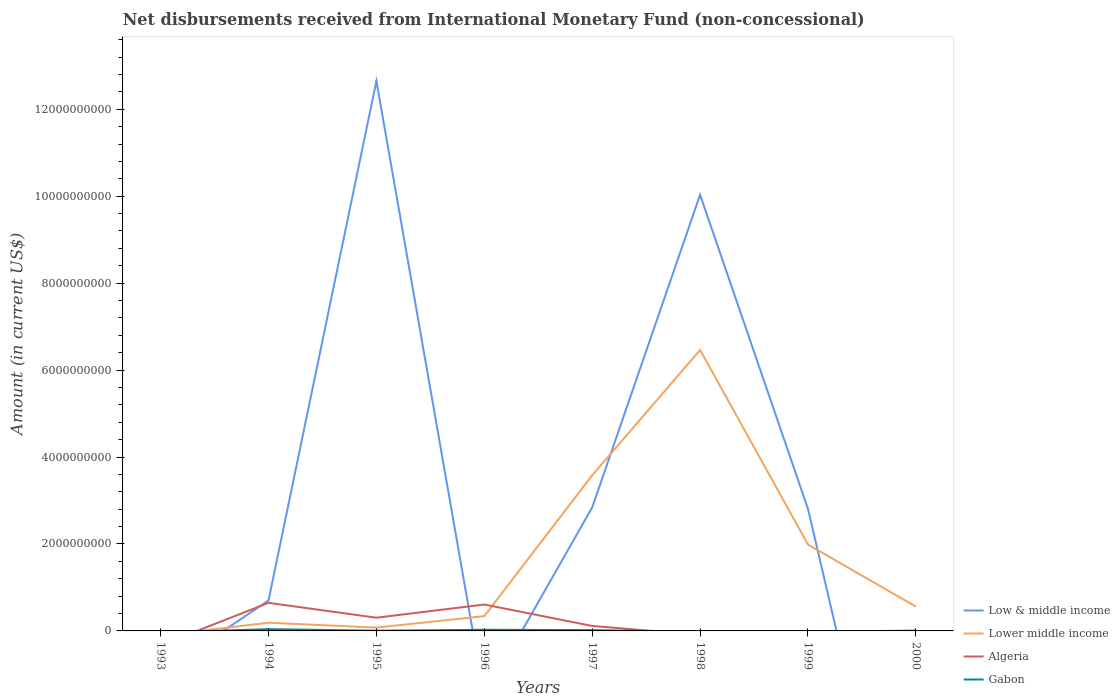Across all years, what is the maximum amount of disbursements received from International Monetary Fund in Low & middle income?
Keep it short and to the point. 0. What is the total amount of disbursements received from International Monetary Fund in Gabon in the graph?
Ensure brevity in your answer.  1.16e+07. What is the difference between the highest and the second highest amount of disbursements received from International Monetary Fund in Algeria?
Provide a short and direct response. 6.46e+08. How many years are there in the graph?
Ensure brevity in your answer.  8. Does the graph contain grids?
Make the answer very short. No. How many legend labels are there?
Offer a very short reply. 4. How are the legend labels stacked?
Keep it short and to the point. Vertical. What is the title of the graph?
Keep it short and to the point. Net disbursements received from International Monetary Fund (non-concessional). Does "Bangladesh" appear as one of the legend labels in the graph?
Provide a succinct answer. No. What is the Amount (in current US$) in Low & middle income in 1993?
Offer a terse response. 0. What is the Amount (in current US$) of Lower middle income in 1993?
Your response must be concise. 0. What is the Amount (in current US$) in Low & middle income in 1994?
Your answer should be very brief. 7.00e+08. What is the Amount (in current US$) of Lower middle income in 1994?
Offer a very short reply. 1.88e+08. What is the Amount (in current US$) of Algeria in 1994?
Ensure brevity in your answer.  6.46e+08. What is the Amount (in current US$) of Gabon in 1994?
Your answer should be very brief. 4.09e+07. What is the Amount (in current US$) in Low & middle income in 1995?
Your answer should be compact. 1.26e+1. What is the Amount (in current US$) in Lower middle income in 1995?
Offer a terse response. 7.66e+07. What is the Amount (in current US$) in Algeria in 1995?
Your answer should be compact. 3.04e+08. What is the Amount (in current US$) of Gabon in 1995?
Make the answer very short. 5.36e+06. What is the Amount (in current US$) in Lower middle income in 1996?
Keep it short and to the point. 3.40e+08. What is the Amount (in current US$) of Algeria in 1996?
Your answer should be compact. 6.08e+08. What is the Amount (in current US$) in Gabon in 1996?
Offer a very short reply. 2.66e+07. What is the Amount (in current US$) in Low & middle income in 1997?
Give a very brief answer. 2.84e+09. What is the Amount (in current US$) of Lower middle income in 1997?
Your answer should be compact. 3.58e+09. What is the Amount (in current US$) of Algeria in 1997?
Offer a very short reply. 1.14e+08. What is the Amount (in current US$) of Gabon in 1997?
Offer a very short reply. 1.92e+07. What is the Amount (in current US$) of Low & middle income in 1998?
Your answer should be compact. 1.00e+1. What is the Amount (in current US$) of Lower middle income in 1998?
Your answer should be compact. 6.46e+09. What is the Amount (in current US$) in Gabon in 1998?
Your answer should be compact. 0. What is the Amount (in current US$) of Low & middle income in 1999?
Offer a very short reply. 2.81e+09. What is the Amount (in current US$) in Lower middle income in 1999?
Offer a very short reply. 1.99e+09. What is the Amount (in current US$) in Low & middle income in 2000?
Keep it short and to the point. 0. What is the Amount (in current US$) of Lower middle income in 2000?
Provide a short and direct response. 5.59e+08. What is the Amount (in current US$) of Gabon in 2000?
Provide a short and direct response. 7.62e+06. Across all years, what is the maximum Amount (in current US$) of Low & middle income?
Ensure brevity in your answer.  1.26e+1. Across all years, what is the maximum Amount (in current US$) in Lower middle income?
Your answer should be compact. 6.46e+09. Across all years, what is the maximum Amount (in current US$) in Algeria?
Make the answer very short. 6.46e+08. Across all years, what is the maximum Amount (in current US$) of Gabon?
Keep it short and to the point. 4.09e+07. What is the total Amount (in current US$) in Low & middle income in the graph?
Your answer should be compact. 2.90e+1. What is the total Amount (in current US$) of Lower middle income in the graph?
Offer a terse response. 1.32e+1. What is the total Amount (in current US$) in Algeria in the graph?
Offer a very short reply. 1.67e+09. What is the total Amount (in current US$) of Gabon in the graph?
Ensure brevity in your answer.  9.96e+07. What is the difference between the Amount (in current US$) of Low & middle income in 1994 and that in 1995?
Make the answer very short. -1.19e+1. What is the difference between the Amount (in current US$) of Lower middle income in 1994 and that in 1995?
Make the answer very short. 1.11e+08. What is the difference between the Amount (in current US$) of Algeria in 1994 and that in 1995?
Keep it short and to the point. 3.42e+08. What is the difference between the Amount (in current US$) in Gabon in 1994 and that in 1995?
Offer a very short reply. 3.55e+07. What is the difference between the Amount (in current US$) in Lower middle income in 1994 and that in 1996?
Keep it short and to the point. -1.52e+08. What is the difference between the Amount (in current US$) of Algeria in 1994 and that in 1996?
Give a very brief answer. 3.84e+07. What is the difference between the Amount (in current US$) of Gabon in 1994 and that in 1996?
Provide a succinct answer. 1.43e+07. What is the difference between the Amount (in current US$) in Low & middle income in 1994 and that in 1997?
Offer a very short reply. -2.14e+09. What is the difference between the Amount (in current US$) in Lower middle income in 1994 and that in 1997?
Provide a succinct answer. -3.39e+09. What is the difference between the Amount (in current US$) of Algeria in 1994 and that in 1997?
Your answer should be very brief. 5.32e+08. What is the difference between the Amount (in current US$) in Gabon in 1994 and that in 1997?
Give a very brief answer. 2.17e+07. What is the difference between the Amount (in current US$) in Low & middle income in 1994 and that in 1998?
Offer a very short reply. -9.33e+09. What is the difference between the Amount (in current US$) of Lower middle income in 1994 and that in 1998?
Your answer should be compact. -6.28e+09. What is the difference between the Amount (in current US$) of Low & middle income in 1994 and that in 1999?
Keep it short and to the point. -2.11e+09. What is the difference between the Amount (in current US$) in Lower middle income in 1994 and that in 1999?
Your response must be concise. -1.80e+09. What is the difference between the Amount (in current US$) in Lower middle income in 1994 and that in 2000?
Keep it short and to the point. -3.71e+08. What is the difference between the Amount (in current US$) of Gabon in 1994 and that in 2000?
Keep it short and to the point. 3.32e+07. What is the difference between the Amount (in current US$) in Lower middle income in 1995 and that in 1996?
Provide a short and direct response. -2.64e+08. What is the difference between the Amount (in current US$) of Algeria in 1995 and that in 1996?
Offer a terse response. -3.04e+08. What is the difference between the Amount (in current US$) in Gabon in 1995 and that in 1996?
Give a very brief answer. -2.12e+07. What is the difference between the Amount (in current US$) in Low & middle income in 1995 and that in 1997?
Ensure brevity in your answer.  9.81e+09. What is the difference between the Amount (in current US$) in Lower middle income in 1995 and that in 1997?
Provide a short and direct response. -3.50e+09. What is the difference between the Amount (in current US$) of Algeria in 1995 and that in 1997?
Give a very brief answer. 1.90e+08. What is the difference between the Amount (in current US$) in Gabon in 1995 and that in 1997?
Make the answer very short. -1.38e+07. What is the difference between the Amount (in current US$) in Low & middle income in 1995 and that in 1998?
Your answer should be very brief. 2.62e+09. What is the difference between the Amount (in current US$) in Lower middle income in 1995 and that in 1998?
Your answer should be very brief. -6.39e+09. What is the difference between the Amount (in current US$) in Low & middle income in 1995 and that in 1999?
Offer a terse response. 9.84e+09. What is the difference between the Amount (in current US$) of Lower middle income in 1995 and that in 1999?
Keep it short and to the point. -1.91e+09. What is the difference between the Amount (in current US$) of Lower middle income in 1995 and that in 2000?
Make the answer very short. -4.82e+08. What is the difference between the Amount (in current US$) of Gabon in 1995 and that in 2000?
Provide a short and direct response. -2.26e+06. What is the difference between the Amount (in current US$) in Lower middle income in 1996 and that in 1997?
Provide a short and direct response. -3.24e+09. What is the difference between the Amount (in current US$) of Algeria in 1996 and that in 1997?
Offer a terse response. 4.93e+08. What is the difference between the Amount (in current US$) in Gabon in 1996 and that in 1997?
Your answer should be very brief. 7.40e+06. What is the difference between the Amount (in current US$) in Lower middle income in 1996 and that in 1998?
Offer a very short reply. -6.12e+09. What is the difference between the Amount (in current US$) in Lower middle income in 1996 and that in 1999?
Offer a terse response. -1.65e+09. What is the difference between the Amount (in current US$) in Lower middle income in 1996 and that in 2000?
Make the answer very short. -2.18e+08. What is the difference between the Amount (in current US$) of Gabon in 1996 and that in 2000?
Give a very brief answer. 1.90e+07. What is the difference between the Amount (in current US$) in Low & middle income in 1997 and that in 1998?
Offer a very short reply. -7.19e+09. What is the difference between the Amount (in current US$) of Lower middle income in 1997 and that in 1998?
Offer a very short reply. -2.88e+09. What is the difference between the Amount (in current US$) of Low & middle income in 1997 and that in 1999?
Make the answer very short. 3.42e+07. What is the difference between the Amount (in current US$) of Lower middle income in 1997 and that in 1999?
Give a very brief answer. 1.59e+09. What is the difference between the Amount (in current US$) of Lower middle income in 1997 and that in 2000?
Give a very brief answer. 3.02e+09. What is the difference between the Amount (in current US$) of Gabon in 1997 and that in 2000?
Your response must be concise. 1.16e+07. What is the difference between the Amount (in current US$) in Low & middle income in 1998 and that in 1999?
Keep it short and to the point. 7.23e+09. What is the difference between the Amount (in current US$) in Lower middle income in 1998 and that in 1999?
Offer a terse response. 4.48e+09. What is the difference between the Amount (in current US$) in Lower middle income in 1998 and that in 2000?
Your answer should be compact. 5.90e+09. What is the difference between the Amount (in current US$) in Lower middle income in 1999 and that in 2000?
Your answer should be compact. 1.43e+09. What is the difference between the Amount (in current US$) in Low & middle income in 1994 and the Amount (in current US$) in Lower middle income in 1995?
Provide a short and direct response. 6.23e+08. What is the difference between the Amount (in current US$) of Low & middle income in 1994 and the Amount (in current US$) of Algeria in 1995?
Ensure brevity in your answer.  3.96e+08. What is the difference between the Amount (in current US$) of Low & middle income in 1994 and the Amount (in current US$) of Gabon in 1995?
Offer a very short reply. 6.95e+08. What is the difference between the Amount (in current US$) of Lower middle income in 1994 and the Amount (in current US$) of Algeria in 1995?
Provide a short and direct response. -1.16e+08. What is the difference between the Amount (in current US$) in Lower middle income in 1994 and the Amount (in current US$) in Gabon in 1995?
Your answer should be compact. 1.83e+08. What is the difference between the Amount (in current US$) of Algeria in 1994 and the Amount (in current US$) of Gabon in 1995?
Provide a short and direct response. 6.41e+08. What is the difference between the Amount (in current US$) of Low & middle income in 1994 and the Amount (in current US$) of Lower middle income in 1996?
Give a very brief answer. 3.60e+08. What is the difference between the Amount (in current US$) of Low & middle income in 1994 and the Amount (in current US$) of Algeria in 1996?
Ensure brevity in your answer.  9.26e+07. What is the difference between the Amount (in current US$) of Low & middle income in 1994 and the Amount (in current US$) of Gabon in 1996?
Offer a very short reply. 6.74e+08. What is the difference between the Amount (in current US$) in Lower middle income in 1994 and the Amount (in current US$) in Algeria in 1996?
Your response must be concise. -4.19e+08. What is the difference between the Amount (in current US$) of Lower middle income in 1994 and the Amount (in current US$) of Gabon in 1996?
Provide a short and direct response. 1.62e+08. What is the difference between the Amount (in current US$) of Algeria in 1994 and the Amount (in current US$) of Gabon in 1996?
Give a very brief answer. 6.19e+08. What is the difference between the Amount (in current US$) of Low & middle income in 1994 and the Amount (in current US$) of Lower middle income in 1997?
Provide a short and direct response. -2.88e+09. What is the difference between the Amount (in current US$) in Low & middle income in 1994 and the Amount (in current US$) in Algeria in 1997?
Ensure brevity in your answer.  5.86e+08. What is the difference between the Amount (in current US$) of Low & middle income in 1994 and the Amount (in current US$) of Gabon in 1997?
Offer a very short reply. 6.81e+08. What is the difference between the Amount (in current US$) of Lower middle income in 1994 and the Amount (in current US$) of Algeria in 1997?
Your response must be concise. 7.40e+07. What is the difference between the Amount (in current US$) in Lower middle income in 1994 and the Amount (in current US$) in Gabon in 1997?
Make the answer very short. 1.69e+08. What is the difference between the Amount (in current US$) of Algeria in 1994 and the Amount (in current US$) of Gabon in 1997?
Keep it short and to the point. 6.27e+08. What is the difference between the Amount (in current US$) of Low & middle income in 1994 and the Amount (in current US$) of Lower middle income in 1998?
Offer a very short reply. -5.76e+09. What is the difference between the Amount (in current US$) in Low & middle income in 1994 and the Amount (in current US$) in Lower middle income in 1999?
Make the answer very short. -1.29e+09. What is the difference between the Amount (in current US$) in Low & middle income in 1994 and the Amount (in current US$) in Lower middle income in 2000?
Give a very brief answer. 1.41e+08. What is the difference between the Amount (in current US$) of Low & middle income in 1994 and the Amount (in current US$) of Gabon in 2000?
Offer a very short reply. 6.92e+08. What is the difference between the Amount (in current US$) of Lower middle income in 1994 and the Amount (in current US$) of Gabon in 2000?
Keep it short and to the point. 1.81e+08. What is the difference between the Amount (in current US$) of Algeria in 1994 and the Amount (in current US$) of Gabon in 2000?
Make the answer very short. 6.38e+08. What is the difference between the Amount (in current US$) in Low & middle income in 1995 and the Amount (in current US$) in Lower middle income in 1996?
Make the answer very short. 1.23e+1. What is the difference between the Amount (in current US$) of Low & middle income in 1995 and the Amount (in current US$) of Algeria in 1996?
Give a very brief answer. 1.20e+1. What is the difference between the Amount (in current US$) of Low & middle income in 1995 and the Amount (in current US$) of Gabon in 1996?
Provide a succinct answer. 1.26e+1. What is the difference between the Amount (in current US$) in Lower middle income in 1995 and the Amount (in current US$) in Algeria in 1996?
Your answer should be very brief. -5.31e+08. What is the difference between the Amount (in current US$) of Lower middle income in 1995 and the Amount (in current US$) of Gabon in 1996?
Keep it short and to the point. 5.01e+07. What is the difference between the Amount (in current US$) of Algeria in 1995 and the Amount (in current US$) of Gabon in 1996?
Keep it short and to the point. 2.77e+08. What is the difference between the Amount (in current US$) of Low & middle income in 1995 and the Amount (in current US$) of Lower middle income in 1997?
Ensure brevity in your answer.  9.07e+09. What is the difference between the Amount (in current US$) in Low & middle income in 1995 and the Amount (in current US$) in Algeria in 1997?
Offer a terse response. 1.25e+1. What is the difference between the Amount (in current US$) of Low & middle income in 1995 and the Amount (in current US$) of Gabon in 1997?
Keep it short and to the point. 1.26e+1. What is the difference between the Amount (in current US$) in Lower middle income in 1995 and the Amount (in current US$) in Algeria in 1997?
Make the answer very short. -3.75e+07. What is the difference between the Amount (in current US$) of Lower middle income in 1995 and the Amount (in current US$) of Gabon in 1997?
Give a very brief answer. 5.75e+07. What is the difference between the Amount (in current US$) in Algeria in 1995 and the Amount (in current US$) in Gabon in 1997?
Ensure brevity in your answer.  2.85e+08. What is the difference between the Amount (in current US$) of Low & middle income in 1995 and the Amount (in current US$) of Lower middle income in 1998?
Offer a very short reply. 6.19e+09. What is the difference between the Amount (in current US$) in Low & middle income in 1995 and the Amount (in current US$) in Lower middle income in 1999?
Provide a succinct answer. 1.07e+1. What is the difference between the Amount (in current US$) in Low & middle income in 1995 and the Amount (in current US$) in Lower middle income in 2000?
Ensure brevity in your answer.  1.21e+1. What is the difference between the Amount (in current US$) in Low & middle income in 1995 and the Amount (in current US$) in Gabon in 2000?
Your answer should be compact. 1.26e+1. What is the difference between the Amount (in current US$) of Lower middle income in 1995 and the Amount (in current US$) of Gabon in 2000?
Ensure brevity in your answer.  6.90e+07. What is the difference between the Amount (in current US$) of Algeria in 1995 and the Amount (in current US$) of Gabon in 2000?
Provide a short and direct response. 2.96e+08. What is the difference between the Amount (in current US$) of Lower middle income in 1996 and the Amount (in current US$) of Algeria in 1997?
Your response must be concise. 2.26e+08. What is the difference between the Amount (in current US$) of Lower middle income in 1996 and the Amount (in current US$) of Gabon in 1997?
Provide a short and direct response. 3.21e+08. What is the difference between the Amount (in current US$) in Algeria in 1996 and the Amount (in current US$) in Gabon in 1997?
Your answer should be compact. 5.88e+08. What is the difference between the Amount (in current US$) of Lower middle income in 1996 and the Amount (in current US$) of Gabon in 2000?
Make the answer very short. 3.33e+08. What is the difference between the Amount (in current US$) of Algeria in 1996 and the Amount (in current US$) of Gabon in 2000?
Give a very brief answer. 6.00e+08. What is the difference between the Amount (in current US$) of Low & middle income in 1997 and the Amount (in current US$) of Lower middle income in 1998?
Offer a terse response. -3.62e+09. What is the difference between the Amount (in current US$) in Low & middle income in 1997 and the Amount (in current US$) in Lower middle income in 1999?
Offer a very short reply. 8.54e+08. What is the difference between the Amount (in current US$) in Low & middle income in 1997 and the Amount (in current US$) in Lower middle income in 2000?
Provide a short and direct response. 2.28e+09. What is the difference between the Amount (in current US$) in Low & middle income in 1997 and the Amount (in current US$) in Gabon in 2000?
Offer a terse response. 2.83e+09. What is the difference between the Amount (in current US$) of Lower middle income in 1997 and the Amount (in current US$) of Gabon in 2000?
Offer a terse response. 3.57e+09. What is the difference between the Amount (in current US$) in Algeria in 1997 and the Amount (in current US$) in Gabon in 2000?
Ensure brevity in your answer.  1.07e+08. What is the difference between the Amount (in current US$) of Low & middle income in 1998 and the Amount (in current US$) of Lower middle income in 1999?
Offer a very short reply. 8.05e+09. What is the difference between the Amount (in current US$) in Low & middle income in 1998 and the Amount (in current US$) in Lower middle income in 2000?
Your answer should be very brief. 9.47e+09. What is the difference between the Amount (in current US$) in Low & middle income in 1998 and the Amount (in current US$) in Gabon in 2000?
Ensure brevity in your answer.  1.00e+1. What is the difference between the Amount (in current US$) in Lower middle income in 1998 and the Amount (in current US$) in Gabon in 2000?
Your response must be concise. 6.46e+09. What is the difference between the Amount (in current US$) in Low & middle income in 1999 and the Amount (in current US$) in Lower middle income in 2000?
Ensure brevity in your answer.  2.25e+09. What is the difference between the Amount (in current US$) of Low & middle income in 1999 and the Amount (in current US$) of Gabon in 2000?
Ensure brevity in your answer.  2.80e+09. What is the difference between the Amount (in current US$) in Lower middle income in 1999 and the Amount (in current US$) in Gabon in 2000?
Your answer should be very brief. 1.98e+09. What is the average Amount (in current US$) in Low & middle income per year?
Your answer should be very brief. 3.63e+09. What is the average Amount (in current US$) of Lower middle income per year?
Your response must be concise. 1.65e+09. What is the average Amount (in current US$) in Algeria per year?
Your response must be concise. 2.09e+08. What is the average Amount (in current US$) of Gabon per year?
Offer a terse response. 1.25e+07. In the year 1994, what is the difference between the Amount (in current US$) in Low & middle income and Amount (in current US$) in Lower middle income?
Keep it short and to the point. 5.12e+08. In the year 1994, what is the difference between the Amount (in current US$) of Low & middle income and Amount (in current US$) of Algeria?
Offer a very short reply. 5.42e+07. In the year 1994, what is the difference between the Amount (in current US$) in Low & middle income and Amount (in current US$) in Gabon?
Make the answer very short. 6.59e+08. In the year 1994, what is the difference between the Amount (in current US$) in Lower middle income and Amount (in current US$) in Algeria?
Ensure brevity in your answer.  -4.58e+08. In the year 1994, what is the difference between the Amount (in current US$) in Lower middle income and Amount (in current US$) in Gabon?
Your response must be concise. 1.47e+08. In the year 1994, what is the difference between the Amount (in current US$) of Algeria and Amount (in current US$) of Gabon?
Offer a terse response. 6.05e+08. In the year 1995, what is the difference between the Amount (in current US$) in Low & middle income and Amount (in current US$) in Lower middle income?
Make the answer very short. 1.26e+1. In the year 1995, what is the difference between the Amount (in current US$) in Low & middle income and Amount (in current US$) in Algeria?
Offer a terse response. 1.23e+1. In the year 1995, what is the difference between the Amount (in current US$) in Low & middle income and Amount (in current US$) in Gabon?
Provide a short and direct response. 1.26e+1. In the year 1995, what is the difference between the Amount (in current US$) in Lower middle income and Amount (in current US$) in Algeria?
Your answer should be compact. -2.27e+08. In the year 1995, what is the difference between the Amount (in current US$) of Lower middle income and Amount (in current US$) of Gabon?
Your answer should be compact. 7.13e+07. In the year 1995, what is the difference between the Amount (in current US$) in Algeria and Amount (in current US$) in Gabon?
Ensure brevity in your answer.  2.99e+08. In the year 1996, what is the difference between the Amount (in current US$) of Lower middle income and Amount (in current US$) of Algeria?
Offer a very short reply. -2.67e+08. In the year 1996, what is the difference between the Amount (in current US$) in Lower middle income and Amount (in current US$) in Gabon?
Your answer should be compact. 3.14e+08. In the year 1996, what is the difference between the Amount (in current US$) in Algeria and Amount (in current US$) in Gabon?
Give a very brief answer. 5.81e+08. In the year 1997, what is the difference between the Amount (in current US$) of Low & middle income and Amount (in current US$) of Lower middle income?
Offer a terse response. -7.39e+08. In the year 1997, what is the difference between the Amount (in current US$) of Low & middle income and Amount (in current US$) of Algeria?
Your answer should be compact. 2.73e+09. In the year 1997, what is the difference between the Amount (in current US$) of Low & middle income and Amount (in current US$) of Gabon?
Offer a very short reply. 2.82e+09. In the year 1997, what is the difference between the Amount (in current US$) in Lower middle income and Amount (in current US$) in Algeria?
Offer a terse response. 3.47e+09. In the year 1997, what is the difference between the Amount (in current US$) in Lower middle income and Amount (in current US$) in Gabon?
Make the answer very short. 3.56e+09. In the year 1997, what is the difference between the Amount (in current US$) in Algeria and Amount (in current US$) in Gabon?
Ensure brevity in your answer.  9.50e+07. In the year 1998, what is the difference between the Amount (in current US$) of Low & middle income and Amount (in current US$) of Lower middle income?
Provide a short and direct response. 3.57e+09. In the year 1999, what is the difference between the Amount (in current US$) of Low & middle income and Amount (in current US$) of Lower middle income?
Give a very brief answer. 8.20e+08. In the year 2000, what is the difference between the Amount (in current US$) of Lower middle income and Amount (in current US$) of Gabon?
Offer a terse response. 5.51e+08. What is the ratio of the Amount (in current US$) of Low & middle income in 1994 to that in 1995?
Give a very brief answer. 0.06. What is the ratio of the Amount (in current US$) in Lower middle income in 1994 to that in 1995?
Offer a terse response. 2.45. What is the ratio of the Amount (in current US$) of Algeria in 1994 to that in 1995?
Offer a very short reply. 2.13. What is the ratio of the Amount (in current US$) in Gabon in 1994 to that in 1995?
Ensure brevity in your answer.  7.63. What is the ratio of the Amount (in current US$) in Lower middle income in 1994 to that in 1996?
Keep it short and to the point. 0.55. What is the ratio of the Amount (in current US$) of Algeria in 1994 to that in 1996?
Make the answer very short. 1.06. What is the ratio of the Amount (in current US$) in Gabon in 1994 to that in 1996?
Your response must be concise. 1.54. What is the ratio of the Amount (in current US$) of Low & middle income in 1994 to that in 1997?
Keep it short and to the point. 0.25. What is the ratio of the Amount (in current US$) in Lower middle income in 1994 to that in 1997?
Offer a terse response. 0.05. What is the ratio of the Amount (in current US$) of Algeria in 1994 to that in 1997?
Provide a succinct answer. 5.66. What is the ratio of the Amount (in current US$) in Gabon in 1994 to that in 1997?
Your answer should be compact. 2.13. What is the ratio of the Amount (in current US$) of Low & middle income in 1994 to that in 1998?
Your answer should be very brief. 0.07. What is the ratio of the Amount (in current US$) of Lower middle income in 1994 to that in 1998?
Make the answer very short. 0.03. What is the ratio of the Amount (in current US$) in Low & middle income in 1994 to that in 1999?
Give a very brief answer. 0.25. What is the ratio of the Amount (in current US$) in Lower middle income in 1994 to that in 1999?
Your answer should be compact. 0.09. What is the ratio of the Amount (in current US$) of Lower middle income in 1994 to that in 2000?
Provide a succinct answer. 0.34. What is the ratio of the Amount (in current US$) in Gabon in 1994 to that in 2000?
Make the answer very short. 5.36. What is the ratio of the Amount (in current US$) of Lower middle income in 1995 to that in 1996?
Provide a succinct answer. 0.23. What is the ratio of the Amount (in current US$) of Algeria in 1995 to that in 1996?
Provide a succinct answer. 0.5. What is the ratio of the Amount (in current US$) of Gabon in 1995 to that in 1996?
Ensure brevity in your answer.  0.2. What is the ratio of the Amount (in current US$) of Low & middle income in 1995 to that in 1997?
Your response must be concise. 4.45. What is the ratio of the Amount (in current US$) of Lower middle income in 1995 to that in 1997?
Make the answer very short. 0.02. What is the ratio of the Amount (in current US$) of Algeria in 1995 to that in 1997?
Offer a terse response. 2.66. What is the ratio of the Amount (in current US$) of Gabon in 1995 to that in 1997?
Ensure brevity in your answer.  0.28. What is the ratio of the Amount (in current US$) in Low & middle income in 1995 to that in 1998?
Keep it short and to the point. 1.26. What is the ratio of the Amount (in current US$) of Lower middle income in 1995 to that in 1998?
Provide a succinct answer. 0.01. What is the ratio of the Amount (in current US$) of Low & middle income in 1995 to that in 1999?
Keep it short and to the point. 4.51. What is the ratio of the Amount (in current US$) in Lower middle income in 1995 to that in 1999?
Give a very brief answer. 0.04. What is the ratio of the Amount (in current US$) in Lower middle income in 1995 to that in 2000?
Give a very brief answer. 0.14. What is the ratio of the Amount (in current US$) in Gabon in 1995 to that in 2000?
Give a very brief answer. 0.7. What is the ratio of the Amount (in current US$) in Lower middle income in 1996 to that in 1997?
Provide a short and direct response. 0.1. What is the ratio of the Amount (in current US$) of Algeria in 1996 to that in 1997?
Your answer should be compact. 5.32. What is the ratio of the Amount (in current US$) in Gabon in 1996 to that in 1997?
Provide a succinct answer. 1.39. What is the ratio of the Amount (in current US$) of Lower middle income in 1996 to that in 1998?
Keep it short and to the point. 0.05. What is the ratio of the Amount (in current US$) in Lower middle income in 1996 to that in 1999?
Your answer should be very brief. 0.17. What is the ratio of the Amount (in current US$) of Lower middle income in 1996 to that in 2000?
Offer a very short reply. 0.61. What is the ratio of the Amount (in current US$) in Gabon in 1996 to that in 2000?
Give a very brief answer. 3.49. What is the ratio of the Amount (in current US$) in Low & middle income in 1997 to that in 1998?
Keep it short and to the point. 0.28. What is the ratio of the Amount (in current US$) of Lower middle income in 1997 to that in 1998?
Ensure brevity in your answer.  0.55. What is the ratio of the Amount (in current US$) in Low & middle income in 1997 to that in 1999?
Your answer should be compact. 1.01. What is the ratio of the Amount (in current US$) in Lower middle income in 1997 to that in 1999?
Make the answer very short. 1.8. What is the ratio of the Amount (in current US$) in Lower middle income in 1997 to that in 2000?
Your answer should be very brief. 6.41. What is the ratio of the Amount (in current US$) in Gabon in 1997 to that in 2000?
Offer a terse response. 2.52. What is the ratio of the Amount (in current US$) in Low & middle income in 1998 to that in 1999?
Offer a very short reply. 3.57. What is the ratio of the Amount (in current US$) of Lower middle income in 1998 to that in 1999?
Keep it short and to the point. 3.25. What is the ratio of the Amount (in current US$) of Lower middle income in 1998 to that in 2000?
Keep it short and to the point. 11.56. What is the ratio of the Amount (in current US$) of Lower middle income in 1999 to that in 2000?
Keep it short and to the point. 3.56. What is the difference between the highest and the second highest Amount (in current US$) of Low & middle income?
Ensure brevity in your answer.  2.62e+09. What is the difference between the highest and the second highest Amount (in current US$) in Lower middle income?
Give a very brief answer. 2.88e+09. What is the difference between the highest and the second highest Amount (in current US$) in Algeria?
Make the answer very short. 3.84e+07. What is the difference between the highest and the second highest Amount (in current US$) in Gabon?
Your answer should be compact. 1.43e+07. What is the difference between the highest and the lowest Amount (in current US$) of Low & middle income?
Give a very brief answer. 1.26e+1. What is the difference between the highest and the lowest Amount (in current US$) in Lower middle income?
Provide a short and direct response. 6.46e+09. What is the difference between the highest and the lowest Amount (in current US$) of Algeria?
Keep it short and to the point. 6.46e+08. What is the difference between the highest and the lowest Amount (in current US$) of Gabon?
Ensure brevity in your answer.  4.09e+07. 